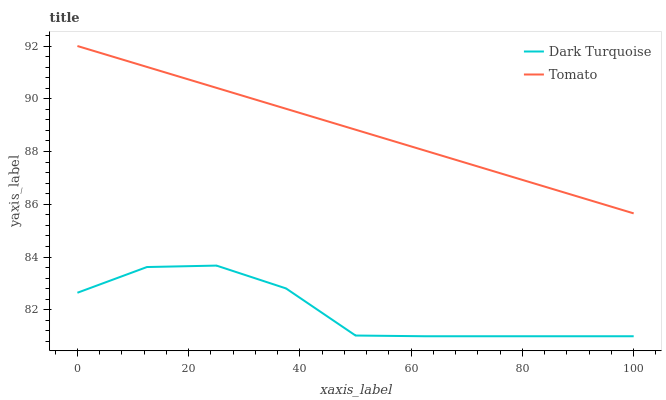Does Dark Turquoise have the minimum area under the curve?
Answer yes or no. Yes. Does Tomato have the maximum area under the curve?
Answer yes or no. Yes. Does Dark Turquoise have the maximum area under the curve?
Answer yes or no. No. Is Tomato the smoothest?
Answer yes or no. Yes. Is Dark Turquoise the roughest?
Answer yes or no. Yes. Is Dark Turquoise the smoothest?
Answer yes or no. No. Does Dark Turquoise have the lowest value?
Answer yes or no. Yes. Does Tomato have the highest value?
Answer yes or no. Yes. Does Dark Turquoise have the highest value?
Answer yes or no. No. Is Dark Turquoise less than Tomato?
Answer yes or no. Yes. Is Tomato greater than Dark Turquoise?
Answer yes or no. Yes. Does Dark Turquoise intersect Tomato?
Answer yes or no. No. 